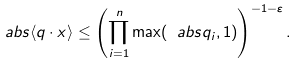<formula> <loc_0><loc_0><loc_500><loc_500>\ a b s { \langle q \cdot x \rangle } \leq \left ( \prod _ { i = 1 } ^ { n } \max ( \ a b s { q _ { i } } , 1 ) \right ) ^ { - 1 - \varepsilon } .</formula> 